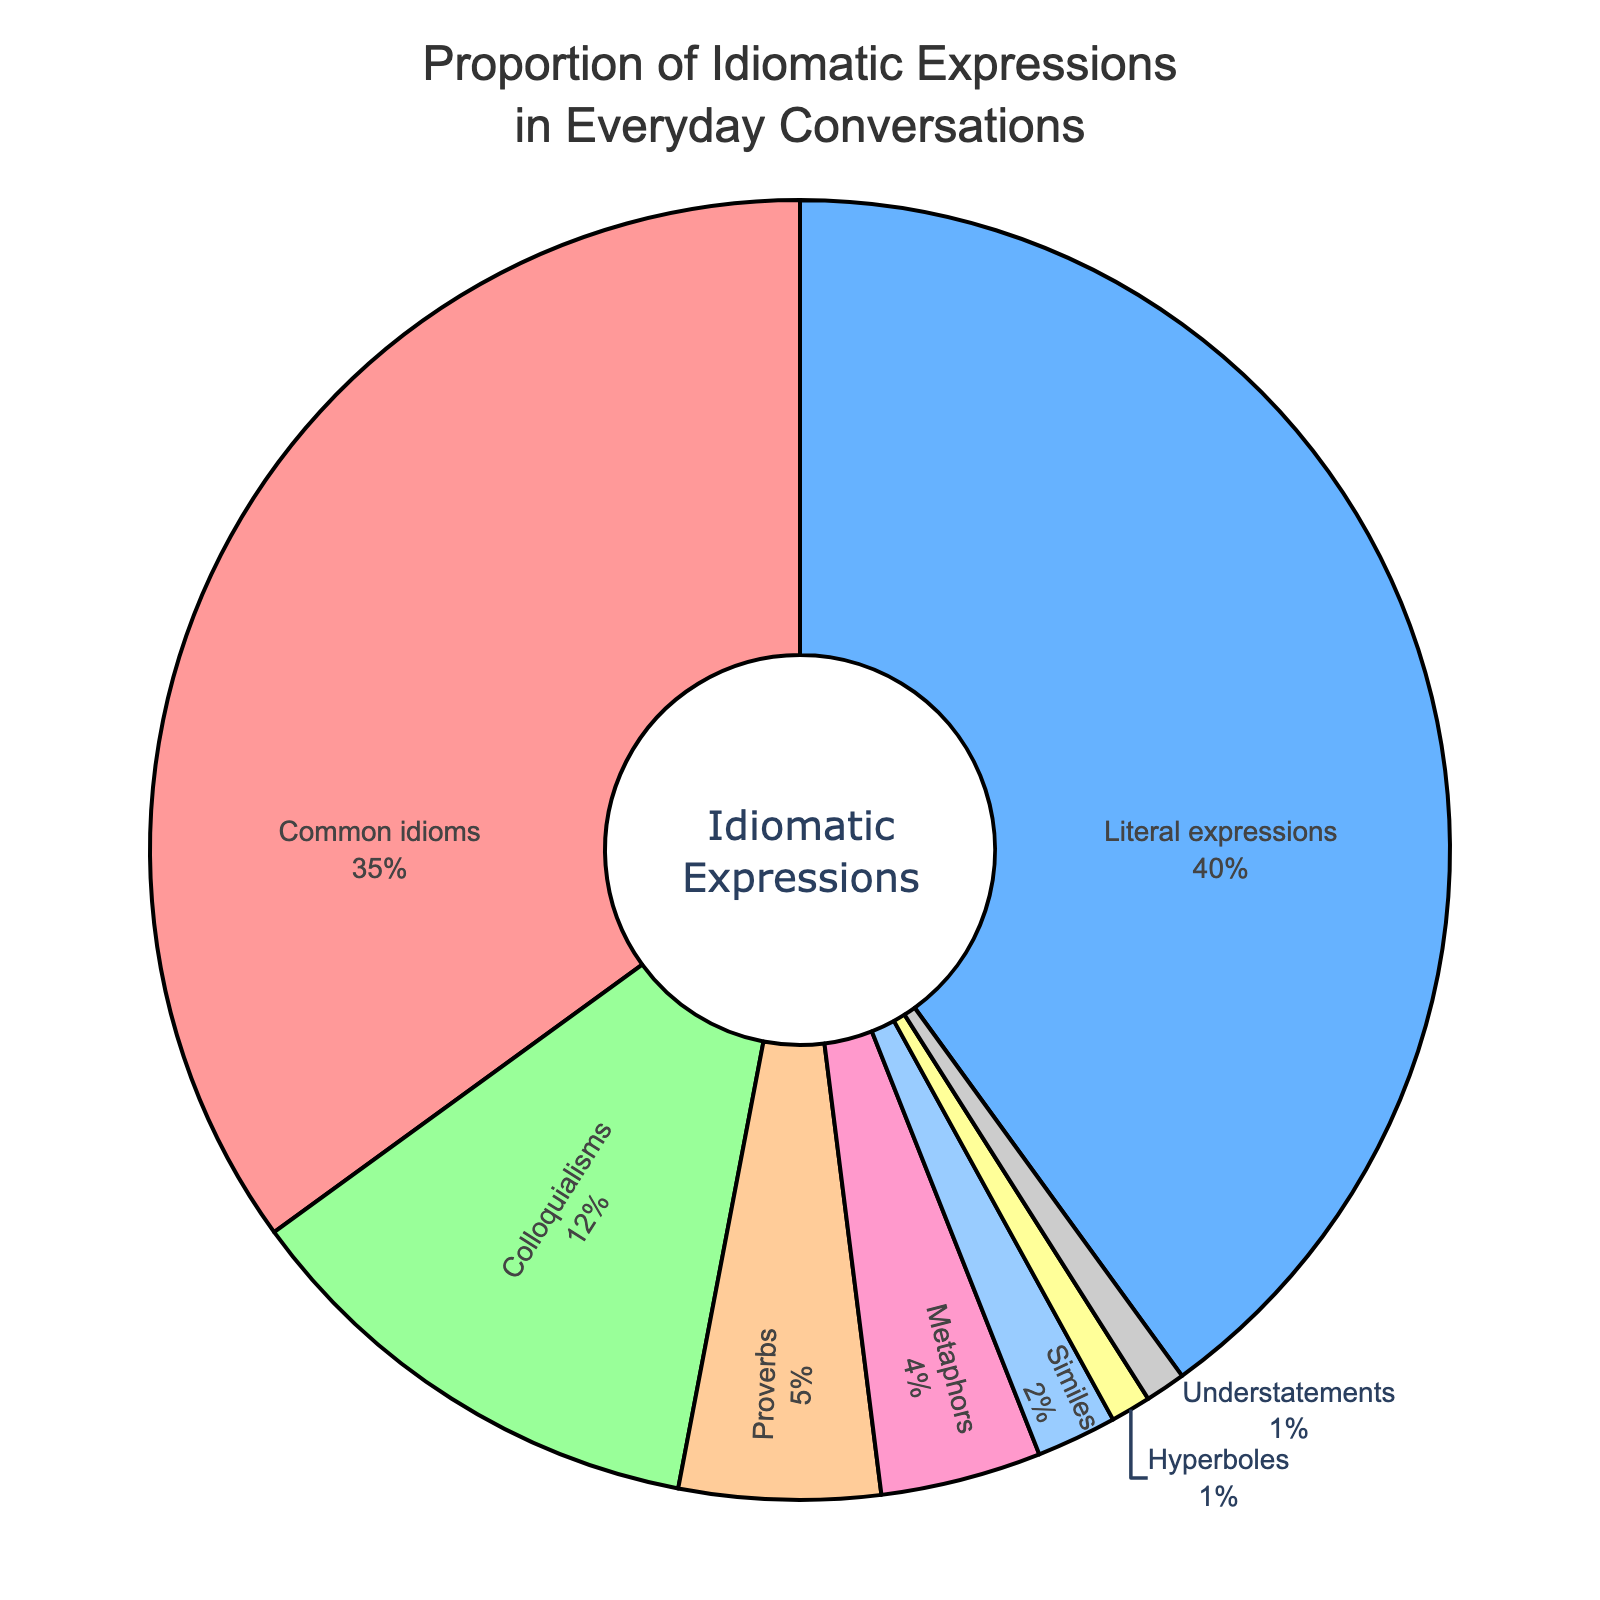What is the most common category of idiomatic expressions? The most common category can be identified by looking at the slice of the pie chart that represents the largest percentage. In this case, "Literal expressions" occupy the largest portion of the pie chart with 40%.
Answer: Literal expressions What is the sum of the percentages of 'Proverbs', 'Metaphors', 'Similes', 'Hyperboles', and 'Understatements'? Sum the percentages of these categories: 5 ('Proverbs') + 4 ('Metaphors') + 2 ('Similes') + 1 ('Hyperboles') + 1 ('Understatements'). These categories collectively represent 13% of the total.
Answer: 13% Which category is represented by the purple slice on the pie chart? The purple color slice in the pie chart represents 'Similes', which accounts for 2% of the data.
Answer: Similes Is the percentage of 'Colloquialisms' greater than 'Metaphors'? If so, by how much? 'Colloquialisms' account for 12% while 'Metaphors' have only 4%. The difference is 12% - 4% = 8%.
Answer: Yes, by 8% What are the three categories with the least percentages? The categories with the smallest percentages can be identified by their values: 'Similes' (2%), 'Hyperboles' (1%), and 'Understatements' (1%).
Answer: Similes, Hyperboles, Understatements What is the combined percentage of the top two most common idiomatic expressions? The top two categories are 'Literal expressions' and 'Common idioms' with percentages 40% and 35% respectively. Adding these gives 40% + 35% = 75%.
Answer: 75% Compare 'Common idioms' and 'Proverbs'. How many times larger is the percentage of 'Common idioms' compared to 'Proverbs'? 'Common idioms' make up 35%, and 'Proverbs' make up 5%. The ratio is 35% / 5% = 7, indicating 'Common idioms' are 7 times more common than 'Proverbs'.
Answer: 7 times What is the percentage difference between the most common and least common categories? The most common category is 'Literal expressions' at 40%, and the least common categories are 'Hyperboles' and 'Understatements' at 1% each. The difference is 40% - 1% = 39%.
Answer: 39% Which category takes up the visually smallest segment of the pie chart? The visually smallest segment is represented by the categories with 1%, which are 'Hyperboles' and 'Understatements'.
Answer: Hyperboles and Understatements What percentage of conversations does 'Colloquialisms' and 'Literal expressions' together make up? Adding the percentages of 'Colloquialisms' (12%) and 'Literal expressions' (40%) results in 12% + 40% = 52%.
Answer: 52% 